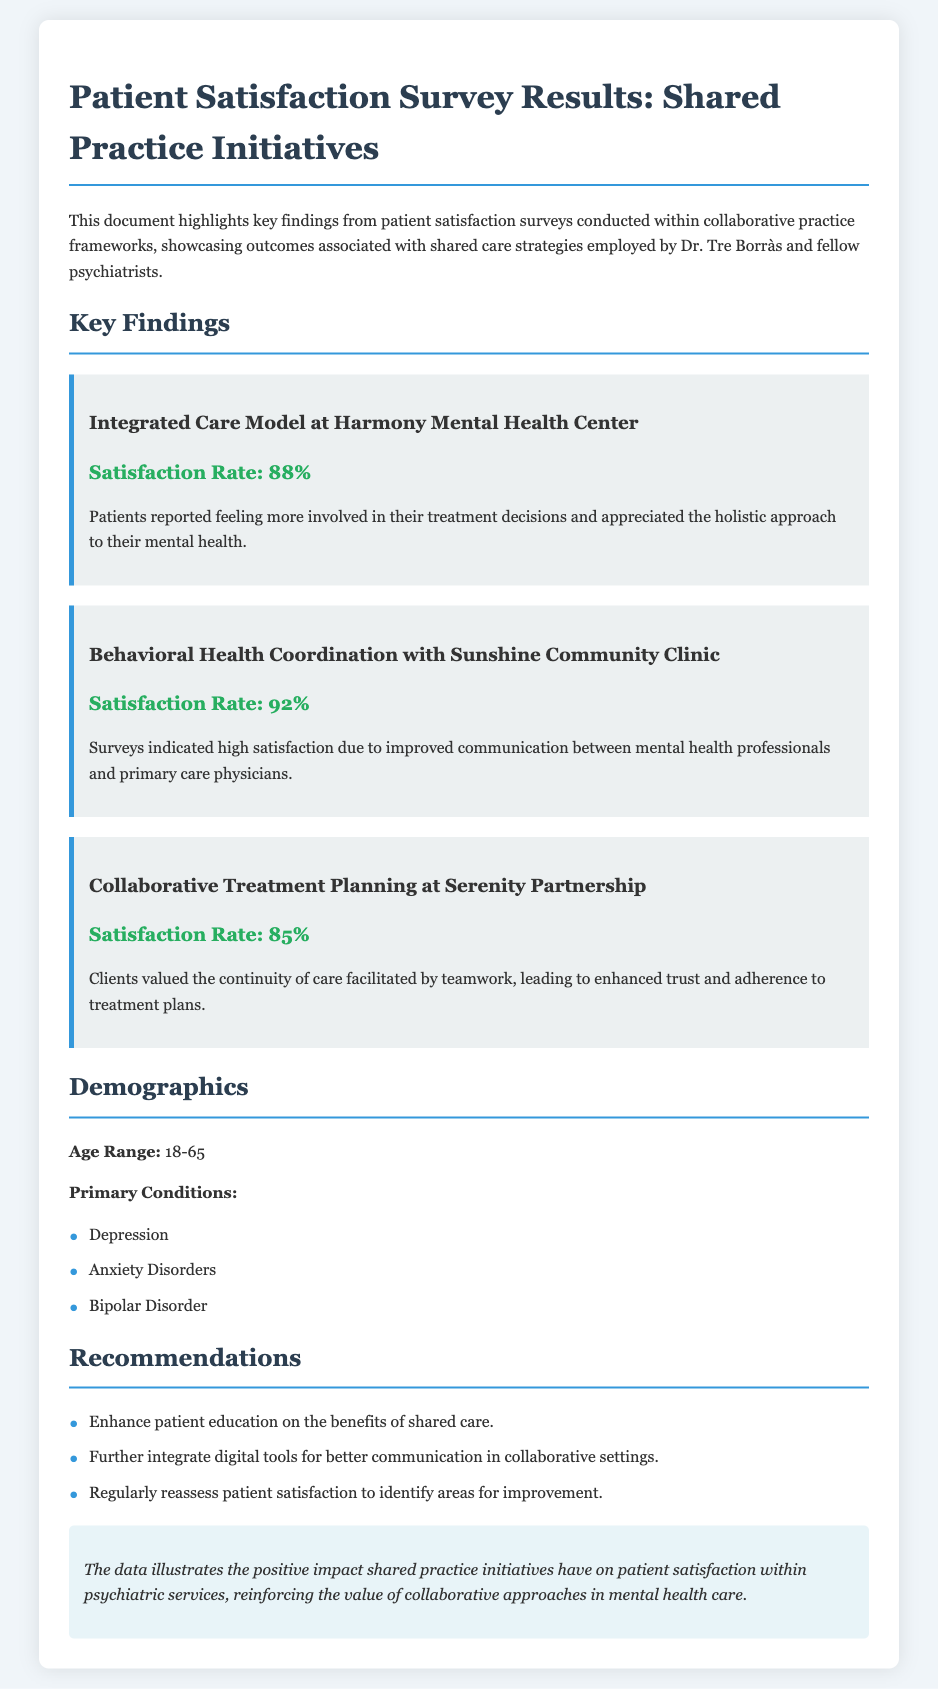What is the satisfaction rate for the Integrated Care Model? The satisfaction rate is explicitly stated in the document as 88%.
Answer: 88% What services were provided at the Sunshine Community Clinic? The document mentions behavioral health coordination as the service provided at this clinic.
Answer: Behavioral Health Coordination What is the primary condition reported by patients in the surveys? The document lists depression, anxiety disorders, and bipolar disorder as the primary conditions.
Answer: Depression Which initiative had the highest satisfaction rate? By comparing the satisfaction rates presented, it is clear that the Behavioral Health Coordination had the highest rate of 92%.
Answer: 92% What is a recommendation made in the document? The document lists several recommendations, one being to enhance patient education on the benefits of shared care.
Answer: Enhance patient education on the benefits of shared care How did patients feel about their involvement in the Integrated Care Model? The document indicates that patients reported feeling more involved in their treatment decisions.
Answer: More involved What age range does the patient demographics cover? The document explicitly states the age range as 18-65.
Answer: 18-65 What is the conclusion regarding shared practice initiatives? The conclusion in the document emphasizes the positive impact on patient satisfaction and the value of collaborative approaches.
Answer: Positive impact on patient satisfaction How many initiatives are discussed in the document? The document lists three distinct initiatives related to shared practice initiatives.
Answer: Three 